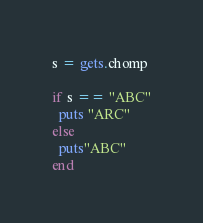<code> <loc_0><loc_0><loc_500><loc_500><_Ruby_>s = gets.chomp

if s == "ABC"
  puts "ARC"
else
  puts"ABC"
end  </code> 